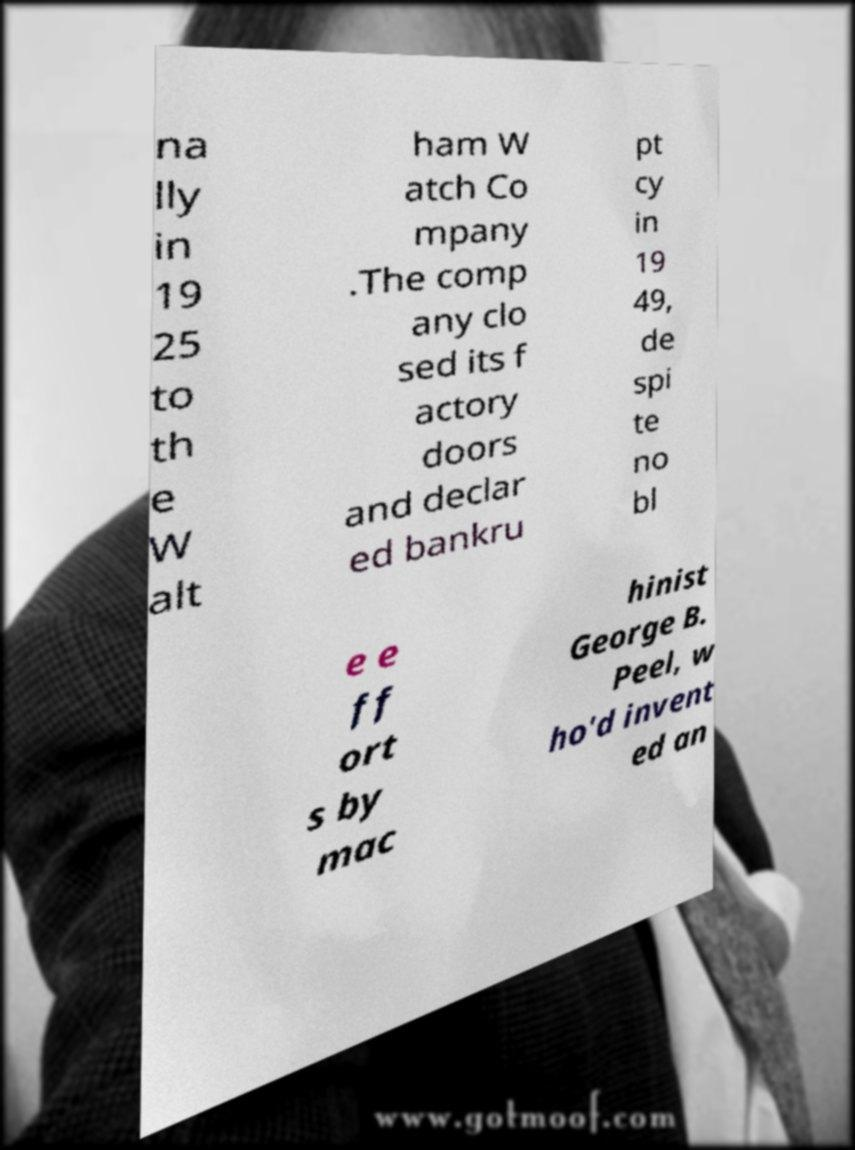For documentation purposes, I need the text within this image transcribed. Could you provide that? na lly in 19 25 to th e W alt ham W atch Co mpany .The comp any clo sed its f actory doors and declar ed bankru pt cy in 19 49, de spi te no bl e e ff ort s by mac hinist George B. Peel, w ho'd invent ed an 